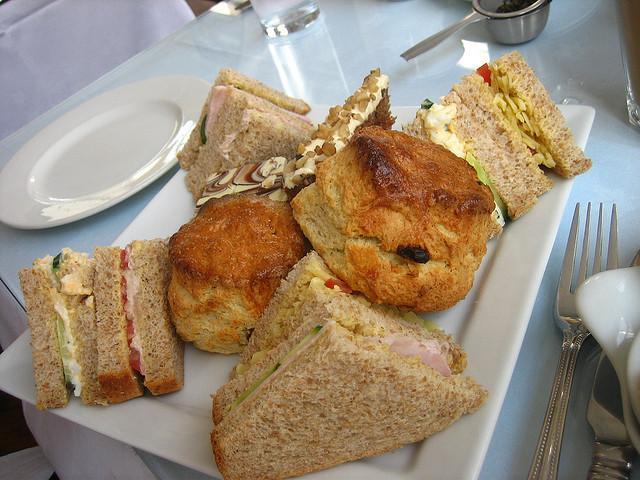How many times was the sandwich cut?
Give a very brief answer. 2. How many dining tables are there?
Give a very brief answer. 1. How many sandwiches can be seen?
Give a very brief answer. 4. How many kites are in the sky?
Give a very brief answer. 0. 